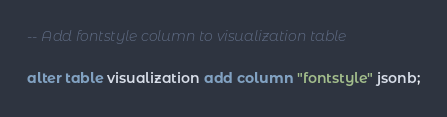Convert code to text. <code><loc_0><loc_0><loc_500><loc_500><_SQL_>
-- Add fontstyle column to visualization table

alter table visualization add column "fontstyle" jsonb;
</code> 